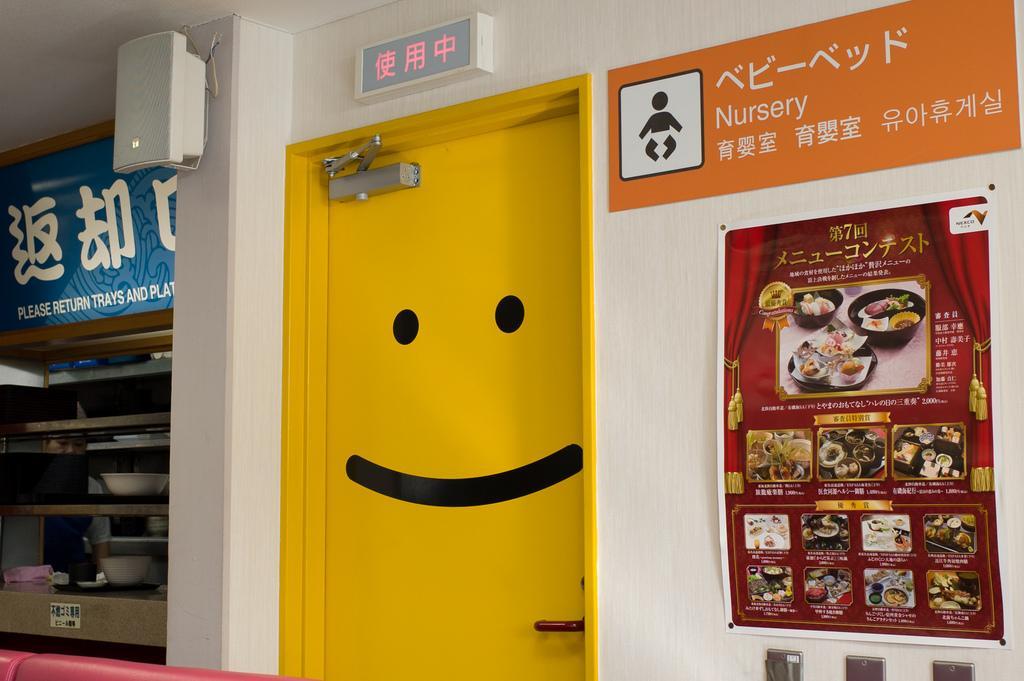Please provide a concise description of this image. In this image in the center there is a door which is yellow in colour. On the right side there are posters on the wall with some text and images on it. On the left side there is the shelf and in the shelf there is a bowl. On the top there is an object hanging on the wall which is white in colour and on the top left side there is a board with some text written on it which is blue in colour. In the front there is an object which is red in colour. 